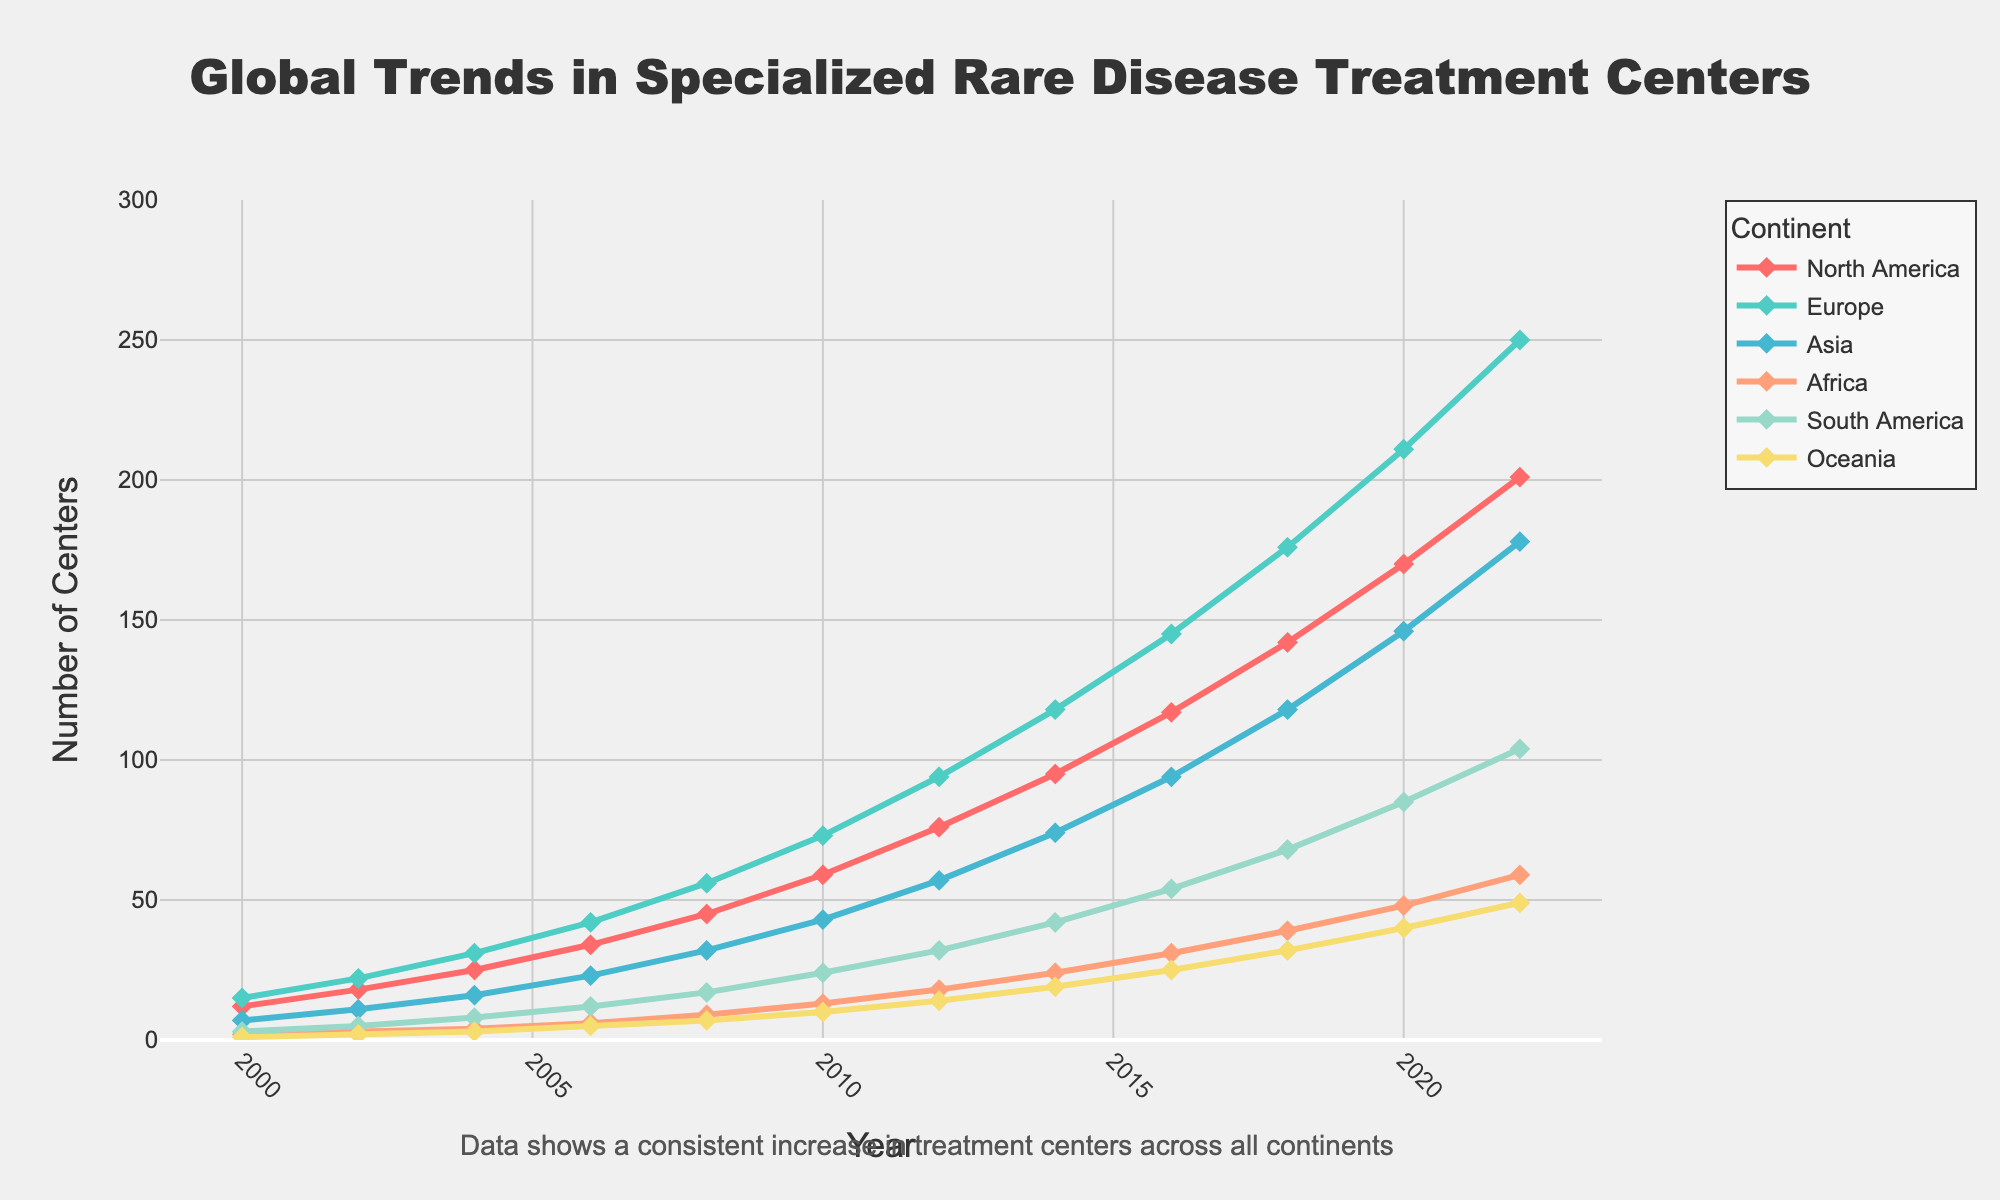What is the total number of specialized rare disease treatment centers established in North America and Europe in 2022? The number of centers in North America in 2022 is 201, and in Europe is 250. Summing these gives: 201 + 250 = 451
Answer: 451 In which year did Asia have approximately the same number of treatment centers as North America in 2008? In 2008, North America had 45 centers. Looking at Asia, the closest number to 45 is 43 in 2010.
Answer: 2010 Which continent had the steepest increase in the number of treatment centers between 2010 and 2012? Comparing the increase for each continent: North America (76-59=17), Europe (94-73=21), Asia (57-43=14), Africa (18-13=5), South America (32-24=8), Oceania (14-10=4). The steepest increase was in Europe.
Answer: Europe By how much did the number of treatment centers in South America grow from 2000 to 2022? In 2000, South America had 3 centers, and in 2022, it had 104 centers. The growth is calculated as: 104 - 3 = 101
Answer: 101 Which two continents had the narrowest gap in the number of treatment centers in 2014? In 2014, the number of centers were: North America (95), Europe (118), Asia (74), Africa (24), South America (42), Oceania (19). The narrowest gap is between South America and Oceania: 42 - 19 = 23
Answer: South America and Oceania Which continent experienced the smallest increase in the number of treatment centers from 2000 to 2022? Calculating the increase for each continent: North America (201-12=189), Europe (250-15=235), Asia (178-7=171), Africa (59-2=57), South America (104-3=101), Oceania (49-1=48). The smallest increase was in Oceania.
Answer: Oceania What was the total number of specialized treatment centers established globally by 2020? Summing the 2020 values: North America (170) + Europe (211) + Asia (146) + Africa (48) + South America (85) + Oceania (40) = 700
Answer: 700 Which continent had the most consistent growth in the number of treatment centers over the years? Observing each continent's graph line consistency, Asia displays the most consistent and steady growth pattern compared to others.
Answer: Asia Between which two consecutive years did North America see the largest increase in the number of treatment centers? North America's centers in specific years: 2000 (12), 2002 (18), 2004 (25), 2006 (34), 2008 (45), 2010 (59), 2012 (76), 2014 (95), 2016 (117), 2018 (142), 2020 (170), 2022 (201). The largest increase is from 2018 to 2020: 170 - 142 = 28
Answer: 2018 to 2020 